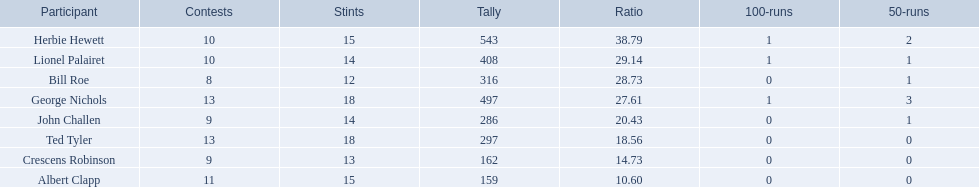Which players played in 10 or fewer matches? Herbie Hewett, Lionel Palairet, Bill Roe, John Challen, Crescens Robinson. Of these, which played in only 12 innings? Bill Roe. 